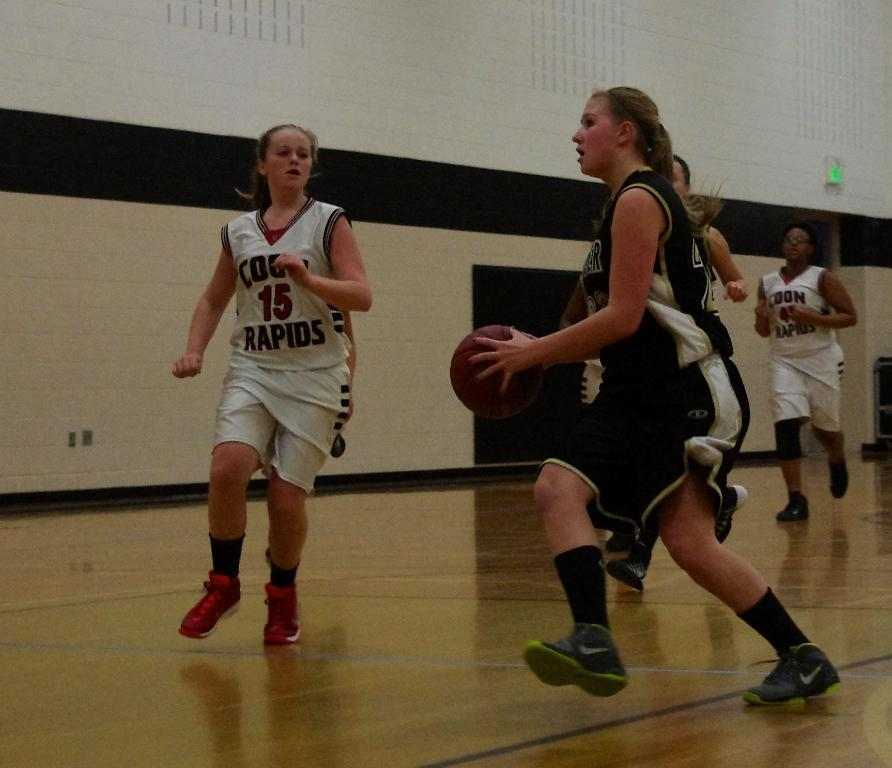What are the people in the image doing? The people are playing basketball in the image. Where is the basketball game taking place? The basketball game is taking place in a room. What can be seen in the background of the image? There is a wall visible in the background of the image. How many lizards are climbing on the rock in the image? There are no lizards or rocks present in the image; it features a group of people playing basketball in a room. 